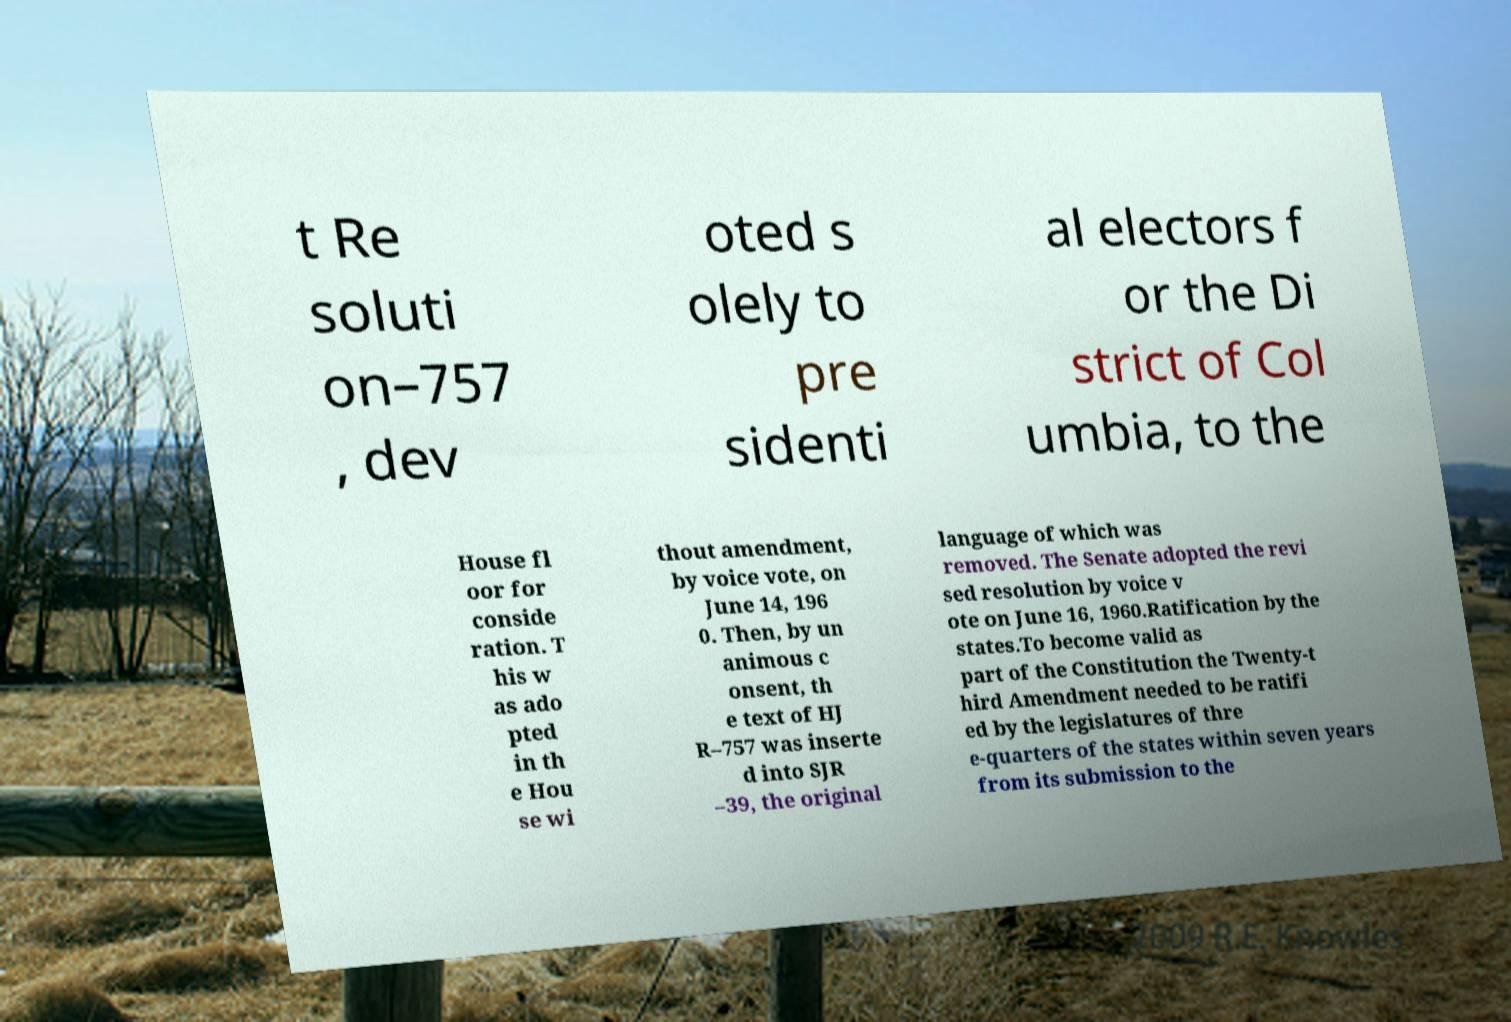For documentation purposes, I need the text within this image transcribed. Could you provide that? t Re soluti on–757 , dev oted s olely to pre sidenti al electors f or the Di strict of Col umbia, to the House fl oor for conside ration. T his w as ado pted in th e Hou se wi thout amendment, by voice vote, on June 14, 196 0. Then, by un animous c onsent, th e text of HJ R–757 was inserte d into SJR –39, the original language of which was removed. The Senate adopted the revi sed resolution by voice v ote on June 16, 1960.Ratification by the states.To become valid as part of the Constitution the Twenty-t hird Amendment needed to be ratifi ed by the legislatures of thre e-quarters of the states within seven years from its submission to the 